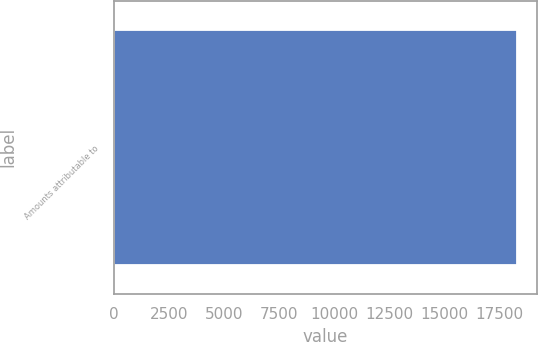<chart> <loc_0><loc_0><loc_500><loc_500><bar_chart><fcel>Amounts attributable to<nl><fcel>18321<nl></chart> 